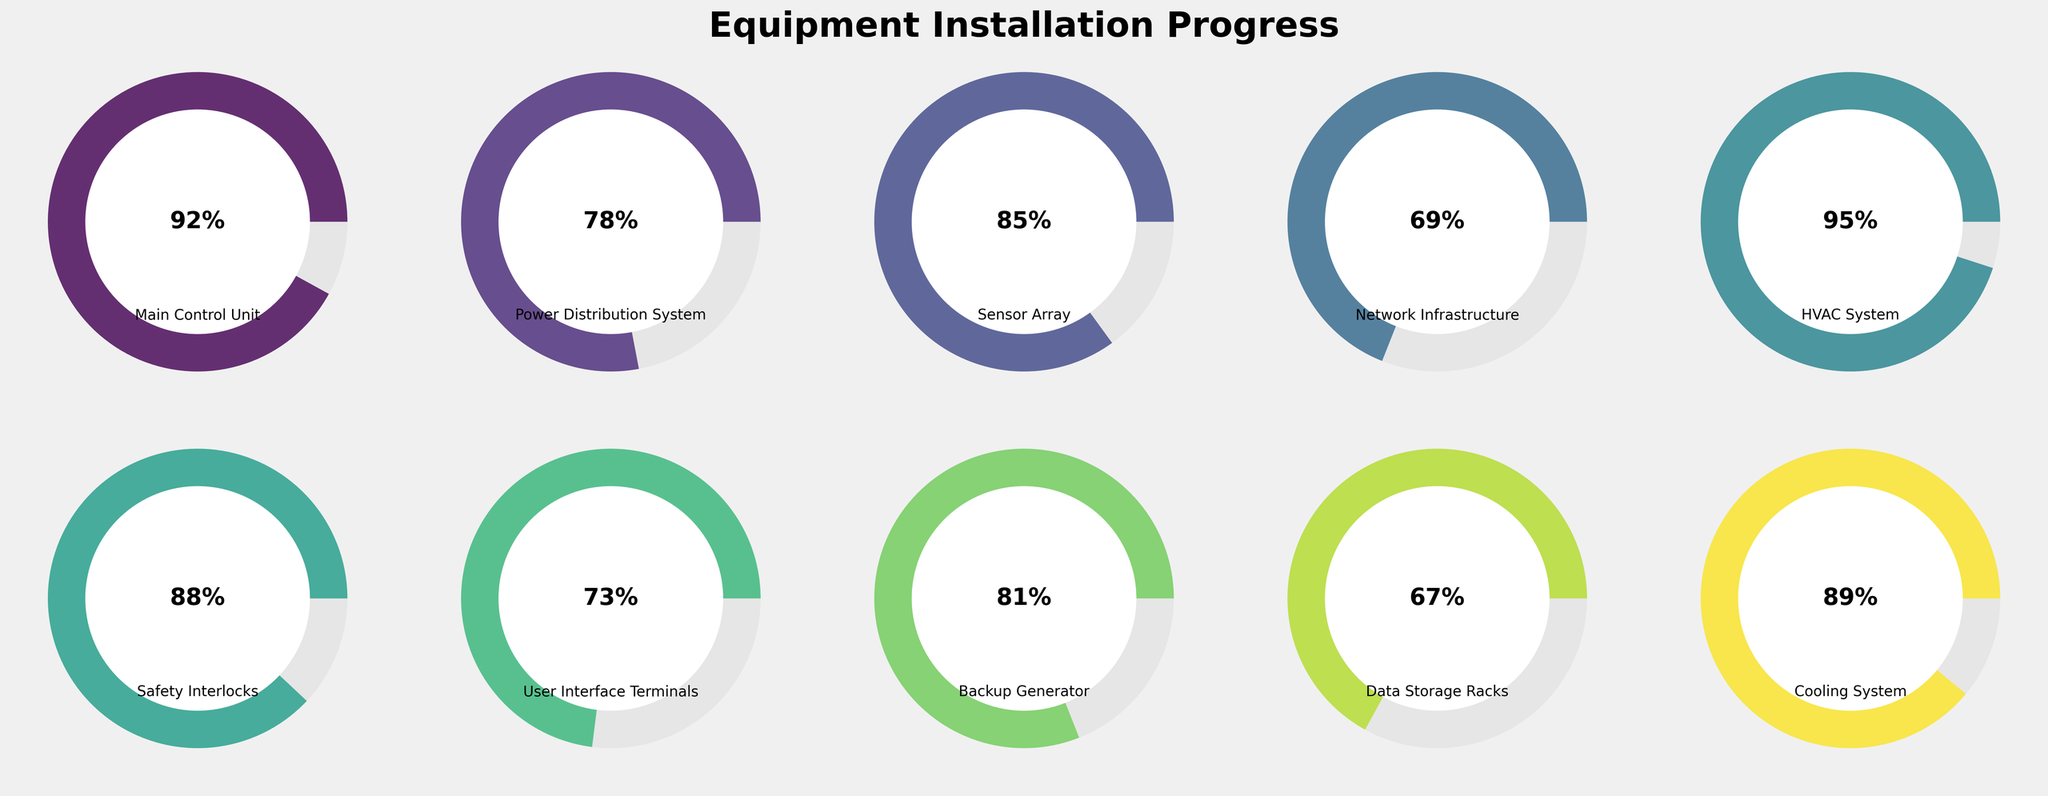What is the title of the figure? The title is usually placed at the top of the figure, providing a summary of the visual content. In this figure, it is displayed prominently.
Answer: Equipment Installation Progress How many components are shown in the figure? To find the number of components, count the number of separate gauge charts displayed. Each gauge represents a single component.
Answer: 10 Which component has the highest percentage completion? Look for the gauge that has the highest filled area and the highest percentage number displayed inside it.
Answer: HVAC System What is the percentage completion of the Network Infrastructure? Identify the gauge labeled as "Network Infrastructure" and check the number displayed inside the gauge.
Answer: 69% What's the average completion percentage of all the components? Sum each of the components' completion percentages: 92 + 78 + 85 + 69 + 95 + 88 + 73 + 81 + 67 + 89. The total is 817. Then, divide by the number of components (10). 817 / 10 = 81.7%
Answer: 81.7% Which component has the lowest percentage completion? Look for the gauge with the smallest filled area and the lowest percentage number displayed.
Answer: Data Storage Racks How many components have a completion percentage of 80% or above? Count the number of gauges where the completion percentage number is 80 or higher: Main Control Unit (92), Sensor Array (85), HVAC System (95), Safety Interlocks (88), and Cooling System (89), making it five components.
Answer: 5 Compare the completion percentages of the User Interface Terminals and the Backup Generator. Which one is higher? Locate the gauges for both User Interface Terminals (73) and Backup Generator (81) and compare the values numerically.
Answer: Backup Generator What is the difference in completion percentage between the Power Distribution System and the Data Storage Racks? Find the completion percentages for both components and subtract the smaller one from the larger: 78 (Power Distribution System) - 67 (Data Storage Racks) = 11%
Answer: 11% If we improve the completion of Network Infrastructure by 15%, what will be the new percentage? Add 15 to the current completion percentage of the Network Infrastructure (69): 69 + 15 = 84%
Answer: 84% 